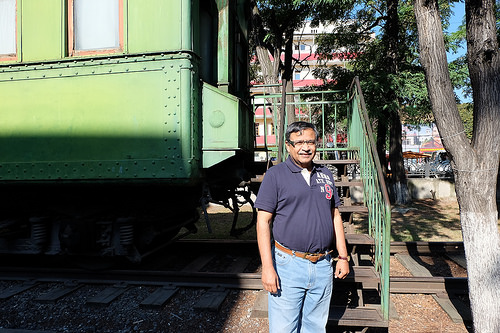<image>
Is the shadow on the train car? Yes. Looking at the image, I can see the shadow is positioned on top of the train car, with the train car providing support. Where is the train in relation to the tree? Is it behind the tree? Yes. From this viewpoint, the train is positioned behind the tree, with the tree partially or fully occluding the train. 